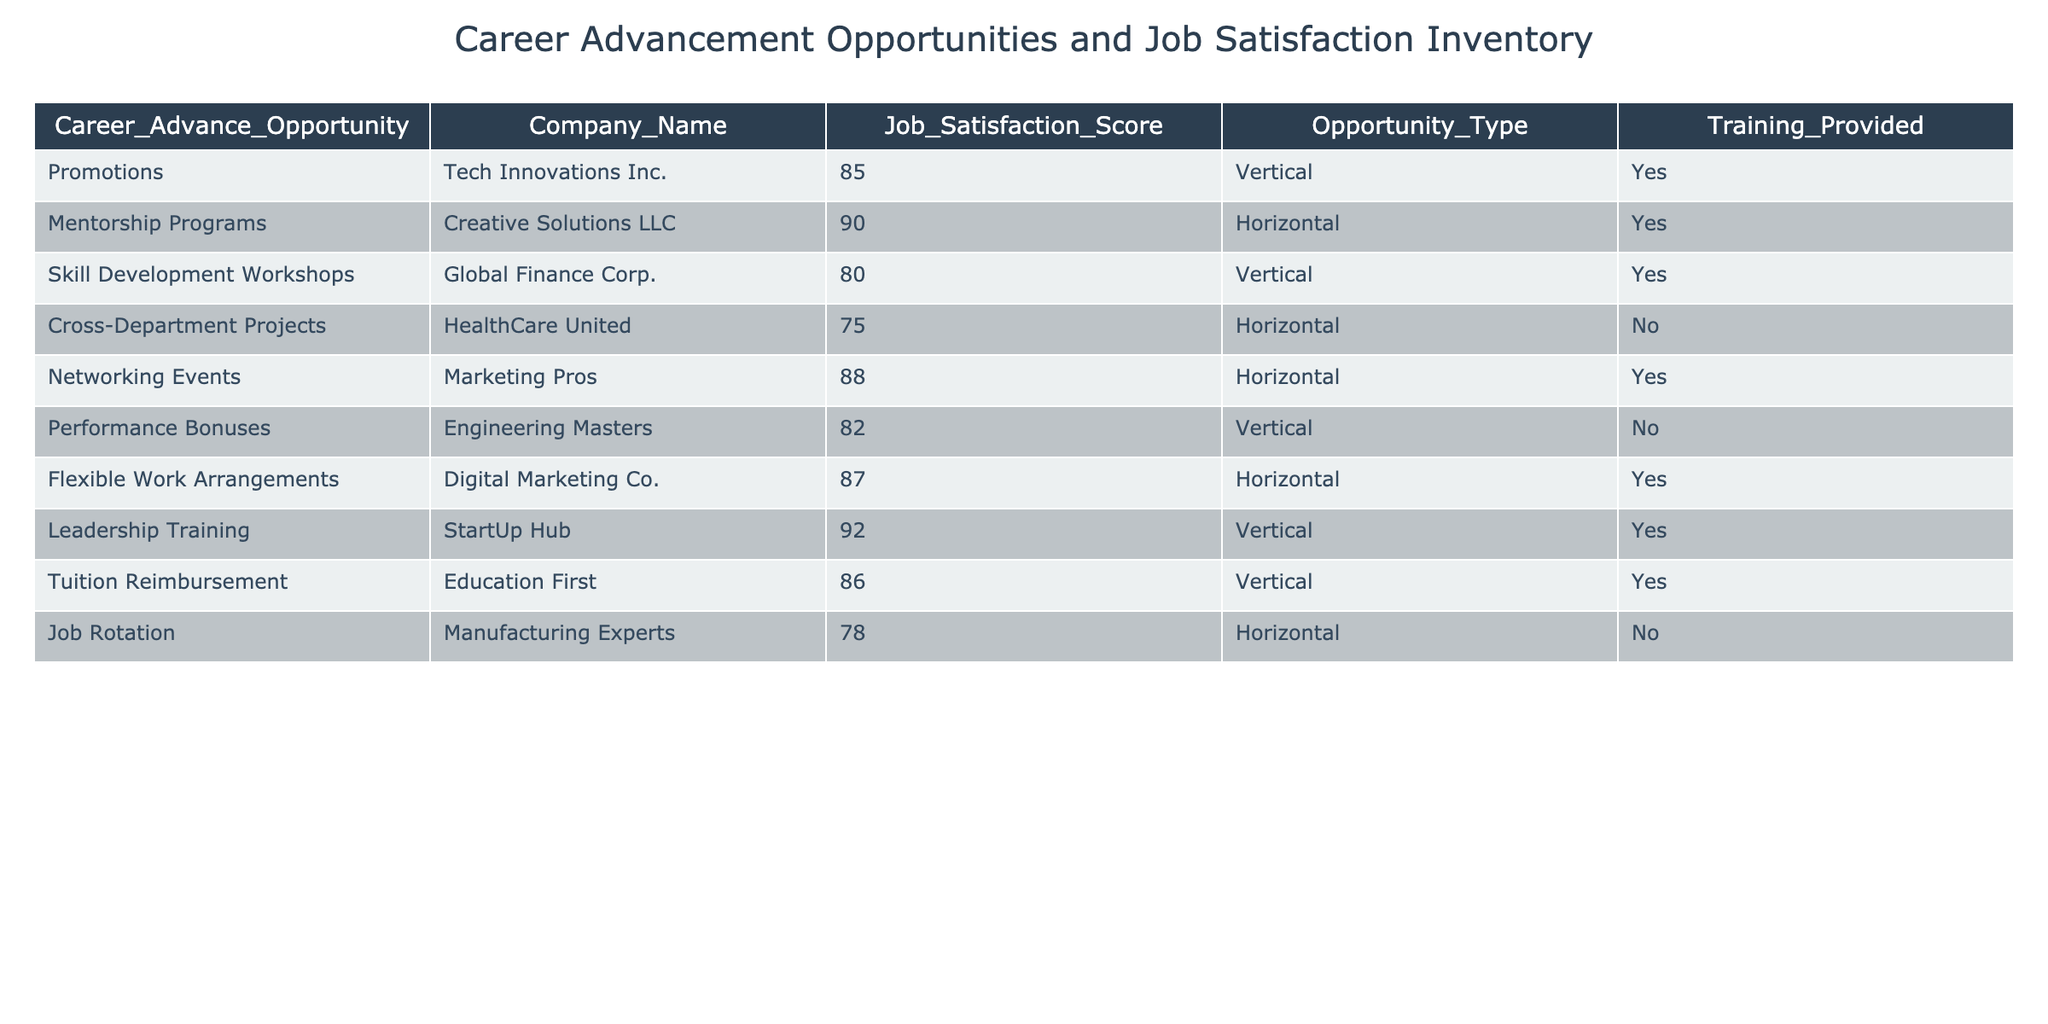What is the job satisfaction score for Tech Innovations Inc.? In the table, I locate the row corresponding to Tech Innovations Inc. The Job Satisfaction Score for this company is listed as 85.
Answer: 85 Which company provides mentorship programs? I scan the Opportunity_Type column to find 'Mentorship Programs.' The corresponding company in that row is Creative Solutions LLC.
Answer: Creative Solutions LLC Are networking events offered by Marketing Pros? The table indicates that Marketing Pros does have networking events since it appears in the row and aligns with Opportunity_Type.
Answer: Yes What is the average job satisfaction score for companies offering horizontal advancement opportunities? I identify the rows with Opportunity_Type listed as 'Horizontal.' The scores are 90, 75, 88, 87, and 78. I sum these up (90 + 75 + 88 + 87 + 78 = 418) and divide by the number of entries (5). The average is 418/5 = 83.6.
Answer: 83.6 Which opportunity type has the highest job satisfaction score? I review the Job Satisfaction scores for each row and determine the maximum value. Leadership Training at StartUp Hub has the highest score of 92.
Answer: Vertical Does Engineering Masters provide any training? I check the Training_Provided column for Engineering Masters, and it states 'No.' Therefore, they do not provide training.
Answer: No Count how many companies provide training for career advancement opportunities. I review the Training_Provided column and count the 'Yes' entries, which appear in the following rows: Tech Innovations Inc., Creative Solutions LLC, Global Finance Corp., Networking Events, Digital Marketing Co., Leadership Training, and Tuition Reimbursement, totaling 6 companies.
Answer: 6 What is the job satisfaction score difference between companies with vertical and horizontal opportunities? I identify Vertical opportunities (85, 80, 82, 92, 86) which average to 84.2, and Horizontal opportunities (90, 75, 88, 87, 78) which average to 83.6. I now calculate the difference (84.2 - 83.6) = 0.6.
Answer: 0.6 Which company has the lowest job satisfaction score among those offering vertical opportunities? I list scores for vertical opportunities: 85, 80, 82, 92, and 86. The lowest score among these is 80 from Global Finance Corp.
Answer: Global Finance Corp 